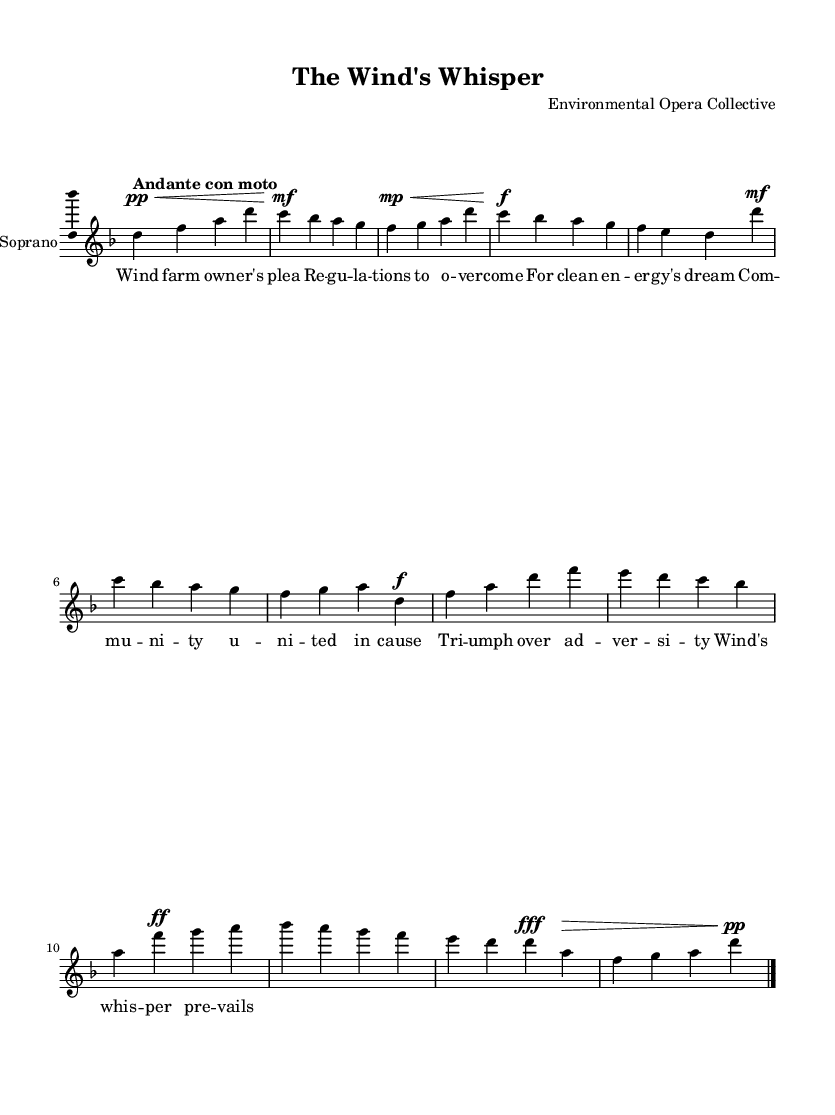What is the key signature of this music? The key signature is determined by the markings at the beginning of the staff. The presence of one flat in the signature indicates that this piece is in D minor.
Answer: D minor What is the time signature of this music? The time signature is found at the beginning of the music and indicates how many beats are in each measure. Here, it shows 4 over 4, meaning there are four beats per measure.
Answer: 4/4 What is the tempo marking for this piece? The tempo marking appears in Italian above the staff, indicating the speed at which the piece should be played. The marking "Andante con moto" suggests a moderately paced tempo with a slight increase in speed.
Answer: Andante con moto How many measures are there in the soprano part? By counting the number of vertical lines that segment the music, you can determine the number of measures. There are six segments in the soprano part.
Answer: 6 What is the dynamic marking of the trio climax? The dynamic marking is indicated right before the climax section of the music. Here, the marking is fortissimo, indicating a very loud passage.
Answer: Fortissimo What is the primary theme's starting note? The primary theme of the aria can initially be identified by the first note written in the soprano part. The first note indicated is D.
Answer: D What type of opera is this composition? The characteristics of the composition, such as its provoking themes around environmental issues and the challenge faced by the protagonist, define it as a dramatic opera.
Answer: Dramatic opera 